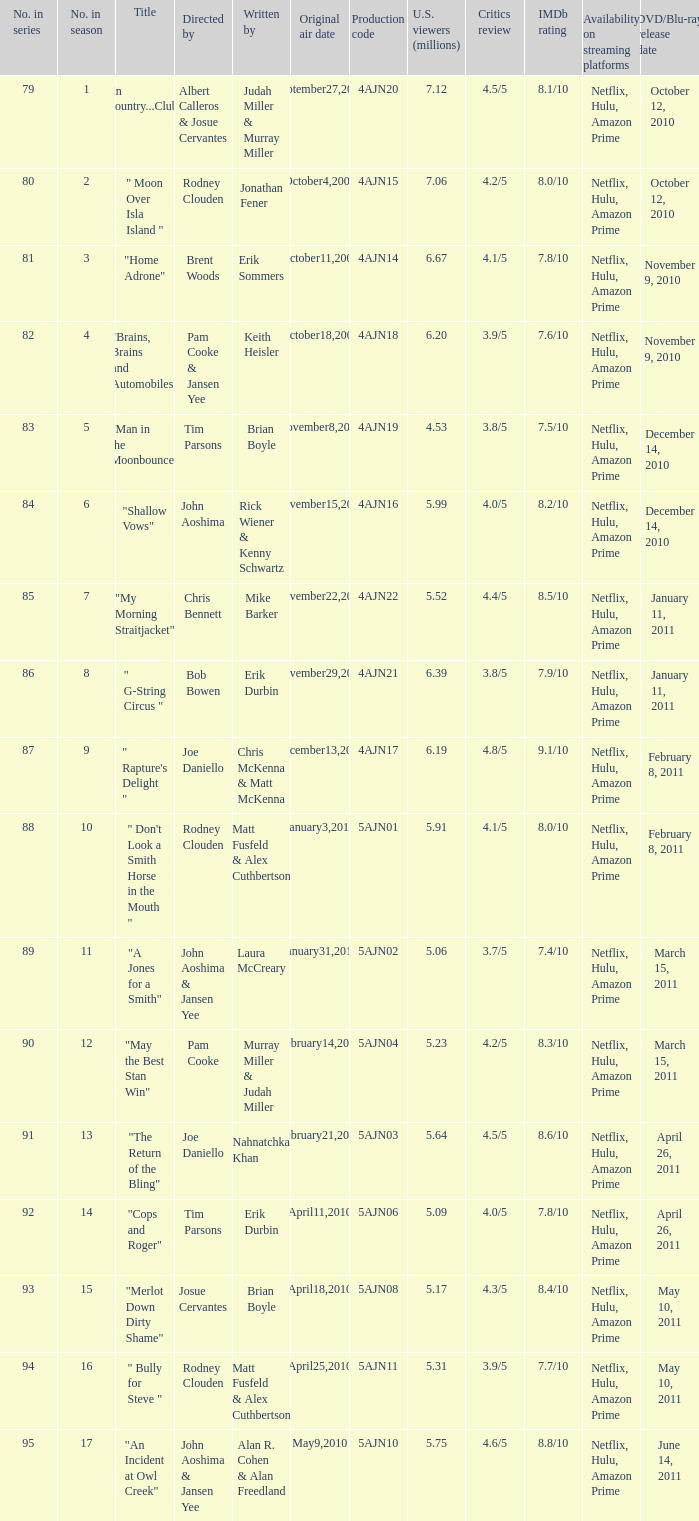Name the original air date for " don't look a smith horse in the mouth " January3,2010. 